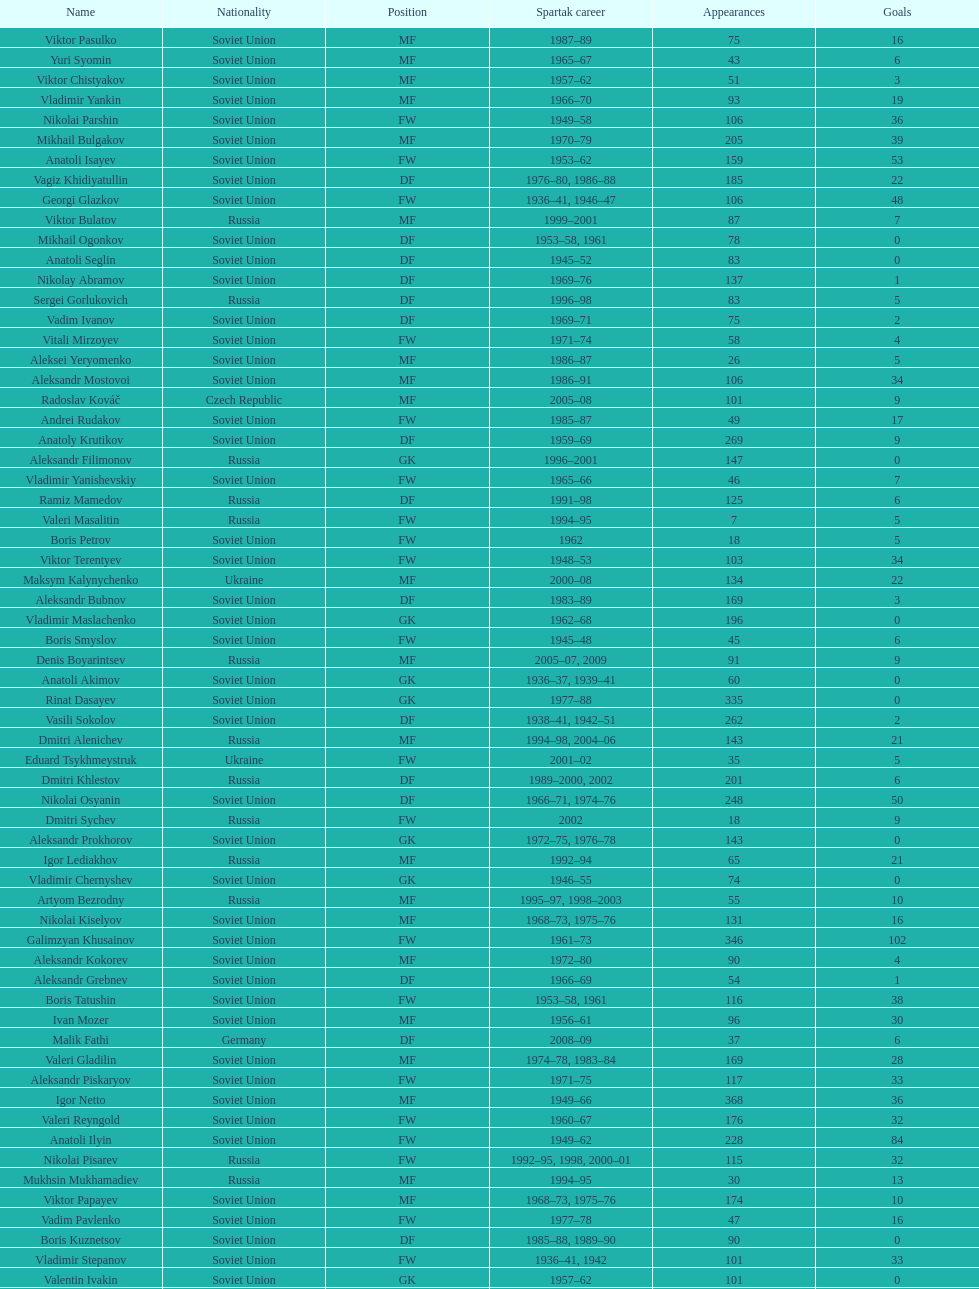How many players had at least 20 league goals scored? 56. 